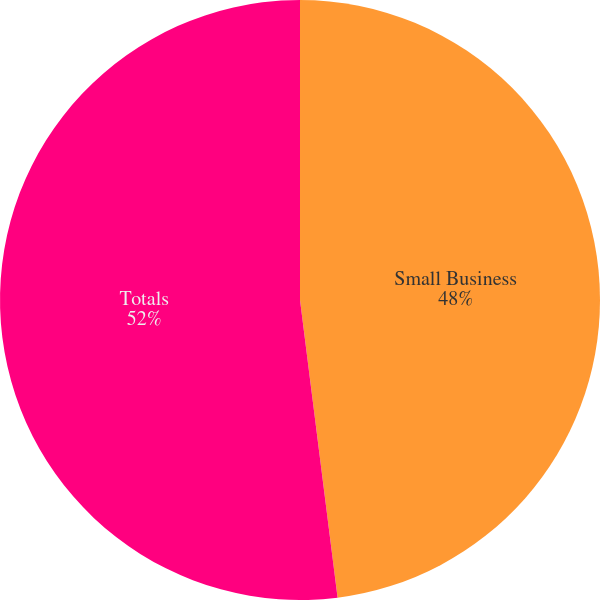Convert chart to OTSL. <chart><loc_0><loc_0><loc_500><loc_500><pie_chart><fcel>Small Business<fcel>Totals<nl><fcel>48.0%<fcel>52.0%<nl></chart> 